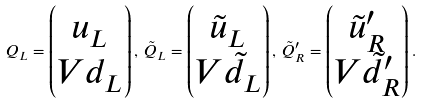Convert formula to latex. <formula><loc_0><loc_0><loc_500><loc_500>Q _ { L } = \begin{pmatrix} u _ { L } \\ V d _ { L } \end{pmatrix} , \, \tilde { Q } _ { L } = \begin{pmatrix} \tilde { u } _ { L } \\ V \tilde { d } _ { L } \end{pmatrix} , \, \tilde { Q } _ { R } ^ { \prime } = \begin{pmatrix} \tilde { u } _ { R } ^ { \prime } \\ V \tilde { d } _ { R } ^ { \prime } \end{pmatrix} .</formula> 